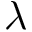Convert formula to latex. <formula><loc_0><loc_0><loc_500><loc_500>\lambda</formula> 